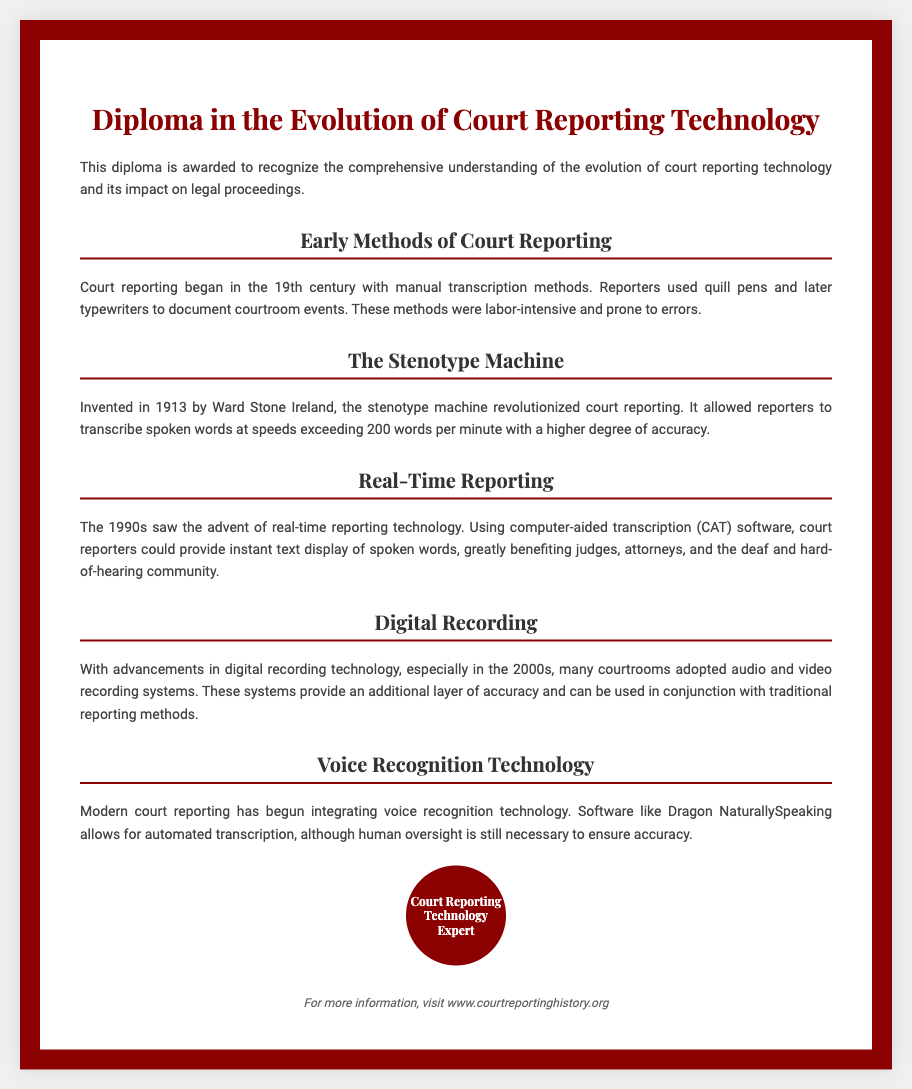What is the title of the diploma? The title of the diploma is prominently displayed at the top of the document.
Answer: Diploma in the Evolution of Court Reporting Technology Who invented the stenotype machine? The document names the inventor of the stenotype machine in the relevant section.
Answer: Ward Stone Ireland In what year was the stenotype machine invented? The year of invention is specified in the section discussing the stenotype machine.
Answer: 1913 What significant technology was introduced in the 1990s for court reporting? The document identifies the key advancement in court reporting from that decade.
Answer: Real-time reporting What technology began integrating with modern court reporting? The document describes an automation technology relevant to current reporting practices.
Answer: Voice recognition technology How did early court reporters document events? The document outlines the traditional methods used in the 19th century for transcription.
Answer: Manual transcription methods What is the purpose of using digital recording technology in courtrooms? The document explains the role of digital systems in enhancing accuracy in legal processes.
Answer: Additional layer of accuracy Which community benefited greatly from real-time reporting? The document mentions a specific group that gained significant advantages from this technological advancement.
Answer: Deaf and hard-of-hearing community 